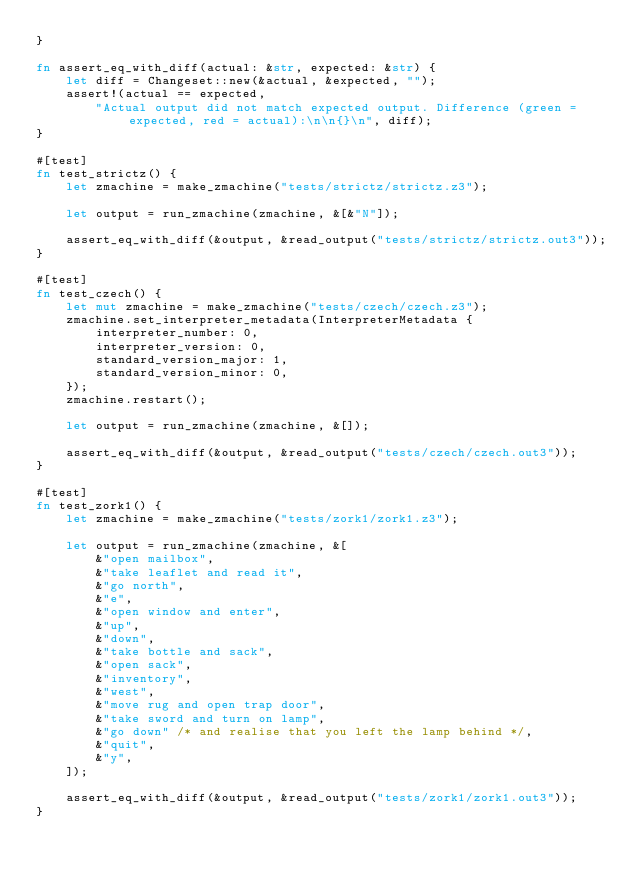<code> <loc_0><loc_0><loc_500><loc_500><_Rust_>}

fn assert_eq_with_diff(actual: &str, expected: &str) {
    let diff = Changeset::new(&actual, &expected, "");
    assert!(actual == expected,
        "Actual output did not match expected output. Difference (green = expected, red = actual):\n\n{}\n", diff);
}

#[test]
fn test_strictz() {
    let zmachine = make_zmachine("tests/strictz/strictz.z3");

    let output = run_zmachine(zmachine, &[&"N"]);

    assert_eq_with_diff(&output, &read_output("tests/strictz/strictz.out3"));
}

#[test]
fn test_czech() {
    let mut zmachine = make_zmachine("tests/czech/czech.z3");
    zmachine.set_interpreter_metadata(InterpreterMetadata {
        interpreter_number: 0,
        interpreter_version: 0,
        standard_version_major: 1,
        standard_version_minor: 0,
    });
    zmachine.restart();

    let output = run_zmachine(zmachine, &[]);

    assert_eq_with_diff(&output, &read_output("tests/czech/czech.out3"));
}

#[test]
fn test_zork1() {
    let zmachine = make_zmachine("tests/zork1/zork1.z3");
    
    let output = run_zmachine(zmachine, &[
        &"open mailbox",
        &"take leaflet and read it",
        &"go north",
        &"e",
        &"open window and enter",
        &"up",
        &"down",
        &"take bottle and sack",
        &"open sack",
        &"inventory",
        &"west",
        &"move rug and open trap door",
        &"take sword and turn on lamp",
        &"go down" /* and realise that you left the lamp behind */,
        &"quit",
        &"y",
    ]);

    assert_eq_with_diff(&output, &read_output("tests/zork1/zork1.out3"));
}
</code> 